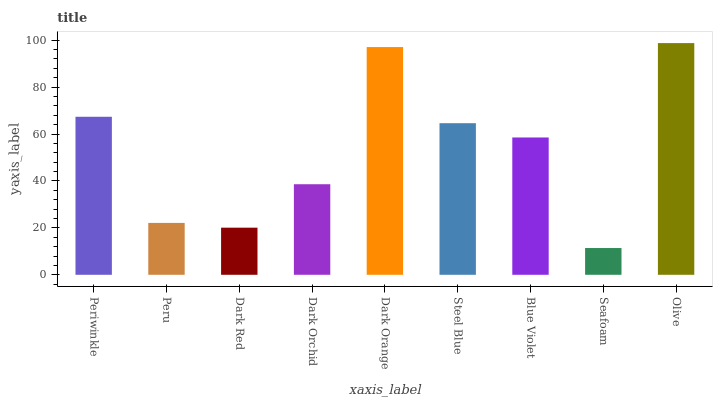Is Seafoam the minimum?
Answer yes or no. Yes. Is Olive the maximum?
Answer yes or no. Yes. Is Peru the minimum?
Answer yes or no. No. Is Peru the maximum?
Answer yes or no. No. Is Periwinkle greater than Peru?
Answer yes or no. Yes. Is Peru less than Periwinkle?
Answer yes or no. Yes. Is Peru greater than Periwinkle?
Answer yes or no. No. Is Periwinkle less than Peru?
Answer yes or no. No. Is Blue Violet the high median?
Answer yes or no. Yes. Is Blue Violet the low median?
Answer yes or no. Yes. Is Peru the high median?
Answer yes or no. No. Is Dark Orchid the low median?
Answer yes or no. No. 